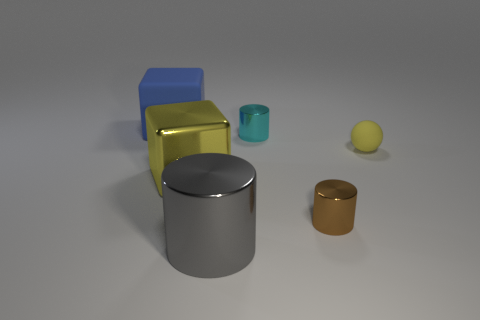Add 1 large matte things. How many objects exist? 7 Subtract all spheres. How many objects are left? 5 Add 5 tiny cyan cylinders. How many tiny cyan cylinders are left? 6 Add 6 small objects. How many small objects exist? 9 Subtract 0 green cylinders. How many objects are left? 6 Subtract all small gray balls. Subtract all large blue things. How many objects are left? 5 